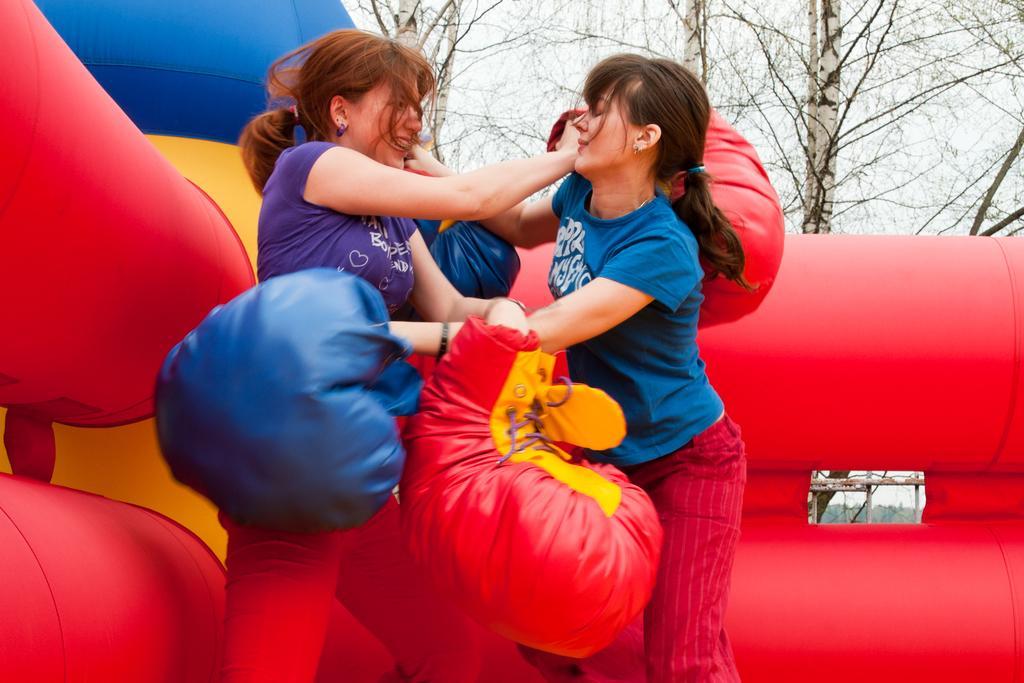Can you describe this image briefly? In this picture there are two women holding object and we can see inflatable objects. In the background of the image we can see trees and sky. 